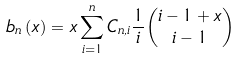<formula> <loc_0><loc_0><loc_500><loc_500>b _ { n } \left ( x \right ) = x \sum _ { i = 1 } ^ { n } C _ { n , i } \frac { 1 } { i } \binom { i - 1 + x } { i - 1 }</formula> 